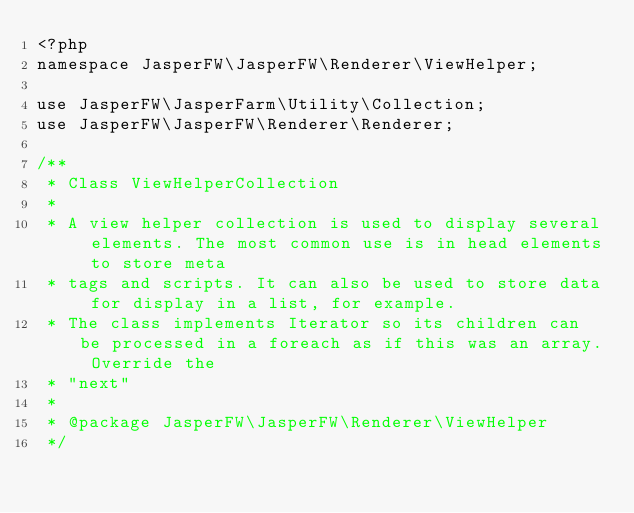Convert code to text. <code><loc_0><loc_0><loc_500><loc_500><_PHP_><?php
namespace JasperFW\JasperFW\Renderer\ViewHelper;

use JasperFW\JasperFarm\Utility\Collection;
use JasperFW\JasperFW\Renderer\Renderer;

/**
 * Class ViewHelperCollection
 *
 * A view helper collection is used to display several elements. The most common use is in head elements to store meta
 * tags and scripts. It can also be used to store data for display in a list, for example.
 * The class implements Iterator so its children can be processed in a foreach as if this was an array. Override the
 * "next"
 *
 * @package JasperFW\JasperFW\Renderer\ViewHelper
 */</code> 